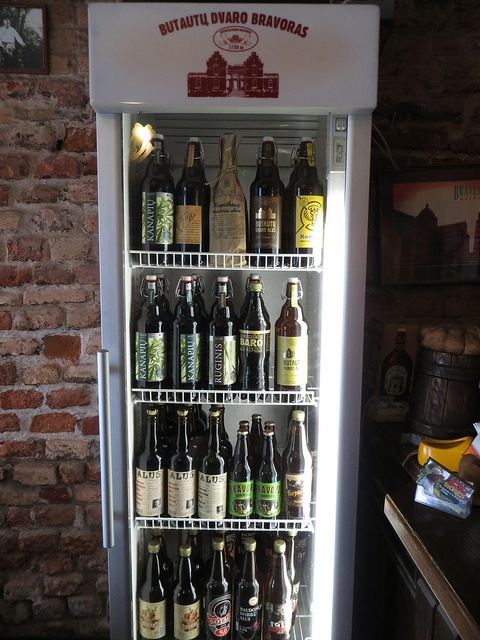Describe the objects in this image and their specific colors. I can see refrigerator in black, gray, white, and darkgray tones, bottle in black, gray, darkgray, and white tones, bottle in black, white, olive, and khaki tones, bottle in black, gray, ivory, and darkgray tones, and bottle in black, gray, darkgray, and purple tones in this image. 